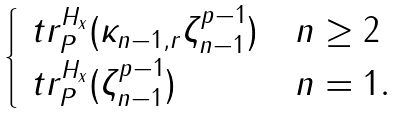Convert formula to latex. <formula><loc_0><loc_0><loc_500><loc_500>\begin{cases} \ t r _ { P } ^ { H _ { x } } ( \kappa _ { n - 1 , r } \zeta ^ { p - 1 } _ { n - 1 } ) & n \geq 2 \\ \ t r _ { P } ^ { H _ { x } } ( \zeta _ { n - 1 } ^ { p - 1 } ) & n = 1 . \end{cases}</formula> 